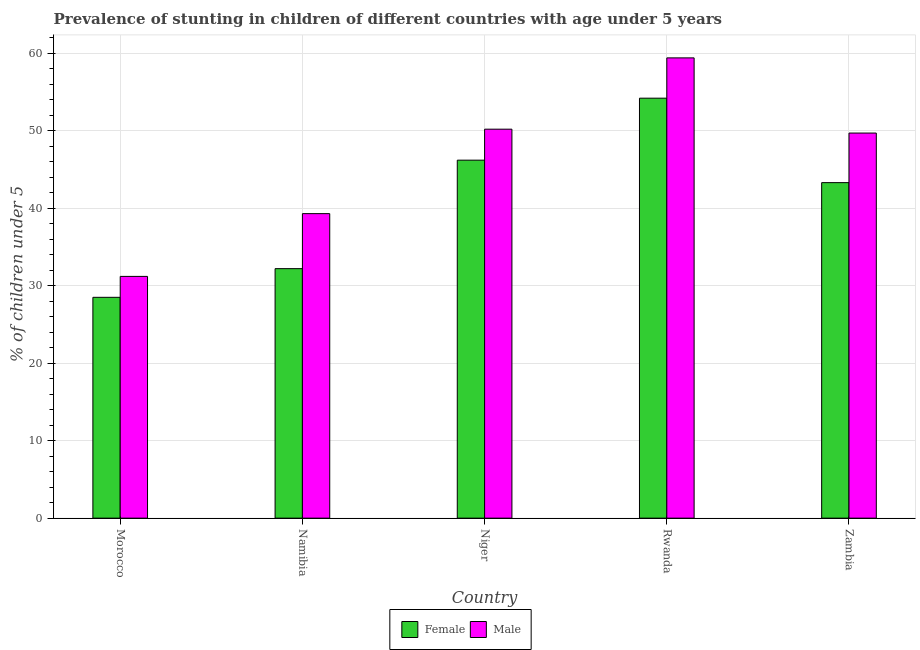How many groups of bars are there?
Give a very brief answer. 5. Are the number of bars per tick equal to the number of legend labels?
Your response must be concise. Yes. Are the number of bars on each tick of the X-axis equal?
Ensure brevity in your answer.  Yes. How many bars are there on the 5th tick from the left?
Offer a terse response. 2. What is the label of the 4th group of bars from the left?
Provide a succinct answer. Rwanda. In how many cases, is the number of bars for a given country not equal to the number of legend labels?
Your answer should be compact. 0. What is the percentage of stunted male children in Morocco?
Provide a succinct answer. 31.2. Across all countries, what is the maximum percentage of stunted female children?
Your answer should be compact. 54.2. Across all countries, what is the minimum percentage of stunted male children?
Offer a terse response. 31.2. In which country was the percentage of stunted female children maximum?
Offer a very short reply. Rwanda. In which country was the percentage of stunted male children minimum?
Provide a short and direct response. Morocco. What is the total percentage of stunted male children in the graph?
Offer a terse response. 229.8. What is the difference between the percentage of stunted male children in Namibia and that in Niger?
Offer a terse response. -10.9. What is the difference between the percentage of stunted female children in Zambia and the percentage of stunted male children in Morocco?
Your response must be concise. 12.1. What is the average percentage of stunted male children per country?
Keep it short and to the point. 45.96. What is the difference between the percentage of stunted male children and percentage of stunted female children in Zambia?
Your response must be concise. 6.4. What is the ratio of the percentage of stunted male children in Rwanda to that in Zambia?
Make the answer very short. 1.2. Is the percentage of stunted female children in Namibia less than that in Rwanda?
Ensure brevity in your answer.  Yes. What is the difference between the highest and the second highest percentage of stunted male children?
Provide a succinct answer. 9.2. What is the difference between the highest and the lowest percentage of stunted male children?
Your response must be concise. 28.2. In how many countries, is the percentage of stunted female children greater than the average percentage of stunted female children taken over all countries?
Provide a succinct answer. 3. Is the sum of the percentage of stunted male children in Morocco and Rwanda greater than the maximum percentage of stunted female children across all countries?
Provide a succinct answer. Yes. What does the 2nd bar from the right in Namibia represents?
Provide a succinct answer. Female. Are all the bars in the graph horizontal?
Keep it short and to the point. No. How many countries are there in the graph?
Your answer should be compact. 5. Where does the legend appear in the graph?
Your answer should be very brief. Bottom center. How many legend labels are there?
Ensure brevity in your answer.  2. How are the legend labels stacked?
Make the answer very short. Horizontal. What is the title of the graph?
Make the answer very short. Prevalence of stunting in children of different countries with age under 5 years. What is the label or title of the Y-axis?
Provide a succinct answer.  % of children under 5. What is the  % of children under 5 in Male in Morocco?
Your response must be concise. 31.2. What is the  % of children under 5 in Female in Namibia?
Give a very brief answer. 32.2. What is the  % of children under 5 in Male in Namibia?
Provide a succinct answer. 39.3. What is the  % of children under 5 in Female in Niger?
Offer a very short reply. 46.2. What is the  % of children under 5 in Male in Niger?
Your response must be concise. 50.2. What is the  % of children under 5 in Female in Rwanda?
Make the answer very short. 54.2. What is the  % of children under 5 of Male in Rwanda?
Provide a short and direct response. 59.4. What is the  % of children under 5 of Female in Zambia?
Keep it short and to the point. 43.3. What is the  % of children under 5 in Male in Zambia?
Keep it short and to the point. 49.7. Across all countries, what is the maximum  % of children under 5 in Female?
Ensure brevity in your answer.  54.2. Across all countries, what is the maximum  % of children under 5 of Male?
Offer a very short reply. 59.4. Across all countries, what is the minimum  % of children under 5 in Male?
Make the answer very short. 31.2. What is the total  % of children under 5 of Female in the graph?
Make the answer very short. 204.4. What is the total  % of children under 5 in Male in the graph?
Your answer should be very brief. 229.8. What is the difference between the  % of children under 5 in Female in Morocco and that in Niger?
Give a very brief answer. -17.7. What is the difference between the  % of children under 5 of Female in Morocco and that in Rwanda?
Keep it short and to the point. -25.7. What is the difference between the  % of children under 5 in Male in Morocco and that in Rwanda?
Make the answer very short. -28.2. What is the difference between the  % of children under 5 in Female in Morocco and that in Zambia?
Provide a short and direct response. -14.8. What is the difference between the  % of children under 5 in Male in Morocco and that in Zambia?
Keep it short and to the point. -18.5. What is the difference between the  % of children under 5 in Male in Namibia and that in Niger?
Your answer should be very brief. -10.9. What is the difference between the  % of children under 5 in Male in Namibia and that in Rwanda?
Your response must be concise. -20.1. What is the difference between the  % of children under 5 of Male in Namibia and that in Zambia?
Provide a succinct answer. -10.4. What is the difference between the  % of children under 5 in Male in Niger and that in Rwanda?
Ensure brevity in your answer.  -9.2. What is the difference between the  % of children under 5 in Female in Niger and that in Zambia?
Your response must be concise. 2.9. What is the difference between the  % of children under 5 in Female in Rwanda and that in Zambia?
Your response must be concise. 10.9. What is the difference between the  % of children under 5 in Male in Rwanda and that in Zambia?
Your answer should be very brief. 9.7. What is the difference between the  % of children under 5 of Female in Morocco and the  % of children under 5 of Male in Namibia?
Offer a very short reply. -10.8. What is the difference between the  % of children under 5 in Female in Morocco and the  % of children under 5 in Male in Niger?
Provide a succinct answer. -21.7. What is the difference between the  % of children under 5 of Female in Morocco and the  % of children under 5 of Male in Rwanda?
Offer a terse response. -30.9. What is the difference between the  % of children under 5 of Female in Morocco and the  % of children under 5 of Male in Zambia?
Your answer should be very brief. -21.2. What is the difference between the  % of children under 5 of Female in Namibia and the  % of children under 5 of Male in Rwanda?
Offer a terse response. -27.2. What is the difference between the  % of children under 5 of Female in Namibia and the  % of children under 5 of Male in Zambia?
Your answer should be very brief. -17.5. What is the difference between the  % of children under 5 in Female in Rwanda and the  % of children under 5 in Male in Zambia?
Give a very brief answer. 4.5. What is the average  % of children under 5 in Female per country?
Give a very brief answer. 40.88. What is the average  % of children under 5 in Male per country?
Your response must be concise. 45.96. What is the difference between the  % of children under 5 of Female and  % of children under 5 of Male in Rwanda?
Your answer should be very brief. -5.2. What is the difference between the  % of children under 5 in Female and  % of children under 5 in Male in Zambia?
Your response must be concise. -6.4. What is the ratio of the  % of children under 5 of Female in Morocco to that in Namibia?
Keep it short and to the point. 0.89. What is the ratio of the  % of children under 5 in Male in Morocco to that in Namibia?
Your answer should be compact. 0.79. What is the ratio of the  % of children under 5 of Female in Morocco to that in Niger?
Offer a terse response. 0.62. What is the ratio of the  % of children under 5 in Male in Morocco to that in Niger?
Offer a very short reply. 0.62. What is the ratio of the  % of children under 5 of Female in Morocco to that in Rwanda?
Ensure brevity in your answer.  0.53. What is the ratio of the  % of children under 5 in Male in Morocco to that in Rwanda?
Offer a very short reply. 0.53. What is the ratio of the  % of children under 5 in Female in Morocco to that in Zambia?
Offer a terse response. 0.66. What is the ratio of the  % of children under 5 in Male in Morocco to that in Zambia?
Give a very brief answer. 0.63. What is the ratio of the  % of children under 5 in Female in Namibia to that in Niger?
Give a very brief answer. 0.7. What is the ratio of the  % of children under 5 in Male in Namibia to that in Niger?
Your answer should be compact. 0.78. What is the ratio of the  % of children under 5 of Female in Namibia to that in Rwanda?
Provide a succinct answer. 0.59. What is the ratio of the  % of children under 5 in Male in Namibia to that in Rwanda?
Provide a succinct answer. 0.66. What is the ratio of the  % of children under 5 in Female in Namibia to that in Zambia?
Provide a short and direct response. 0.74. What is the ratio of the  % of children under 5 in Male in Namibia to that in Zambia?
Offer a very short reply. 0.79. What is the ratio of the  % of children under 5 in Female in Niger to that in Rwanda?
Ensure brevity in your answer.  0.85. What is the ratio of the  % of children under 5 of Male in Niger to that in Rwanda?
Keep it short and to the point. 0.85. What is the ratio of the  % of children under 5 in Female in Niger to that in Zambia?
Your answer should be very brief. 1.07. What is the ratio of the  % of children under 5 of Female in Rwanda to that in Zambia?
Offer a very short reply. 1.25. What is the ratio of the  % of children under 5 of Male in Rwanda to that in Zambia?
Your response must be concise. 1.2. What is the difference between the highest and the second highest  % of children under 5 in Male?
Make the answer very short. 9.2. What is the difference between the highest and the lowest  % of children under 5 in Female?
Offer a very short reply. 25.7. What is the difference between the highest and the lowest  % of children under 5 in Male?
Your answer should be compact. 28.2. 